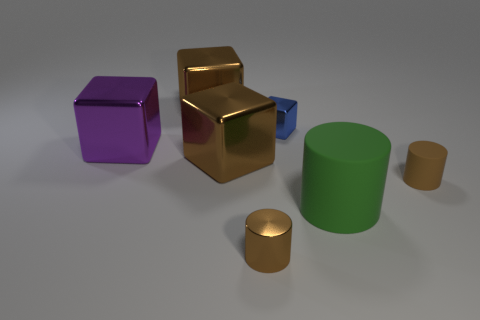What number of green matte spheres are there?
Your response must be concise. 0. What number of objects are metallic objects in front of the large rubber cylinder or large brown shiny objects that are in front of the purple metallic cube?
Keep it short and to the point. 2. There is a brown metallic thing that is in front of the green matte thing; does it have the same size as the large rubber cylinder?
Provide a succinct answer. No. There is a green matte thing that is the same shape as the small brown metallic thing; what size is it?
Ensure brevity in your answer.  Large. What is the material of the other brown cylinder that is the same size as the metallic cylinder?
Make the answer very short. Rubber. What material is the large thing that is the same shape as the tiny brown rubber thing?
Offer a terse response. Rubber. What number of other objects are there of the same size as the green matte thing?
Offer a terse response. 3. What number of large metallic things are the same color as the tiny cube?
Provide a succinct answer. 0. There is a big green object; what shape is it?
Offer a terse response. Cylinder. The metal thing that is in front of the purple cube and to the left of the tiny shiny cylinder is what color?
Your response must be concise. Brown. 